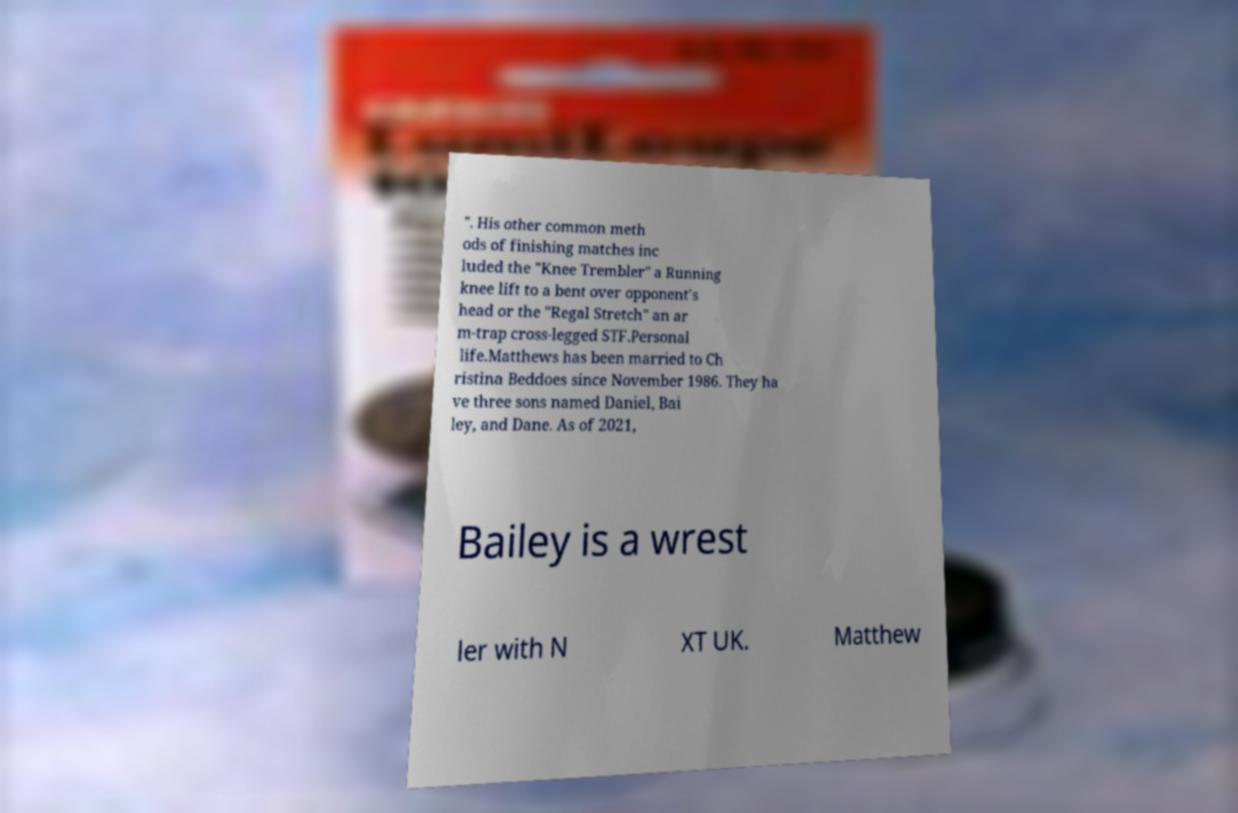What messages or text are displayed in this image? I need them in a readable, typed format. ". His other common meth ods of finishing matches inc luded the "Knee Trembler" a Running knee lift to a bent over opponent's head or the "Regal Stretch" an ar m-trap cross-legged STF.Personal life.Matthews has been married to Ch ristina Beddoes since November 1986. They ha ve three sons named Daniel, Bai ley, and Dane. As of 2021, Bailey is a wrest ler with N XT UK. Matthew 